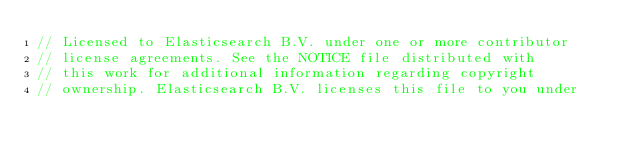Convert code to text. <code><loc_0><loc_0><loc_500><loc_500><_Go_>// Licensed to Elasticsearch B.V. under one or more contributor
// license agreements. See the NOTICE file distributed with
// this work for additional information regarding copyright
// ownership. Elasticsearch B.V. licenses this file to you under</code> 